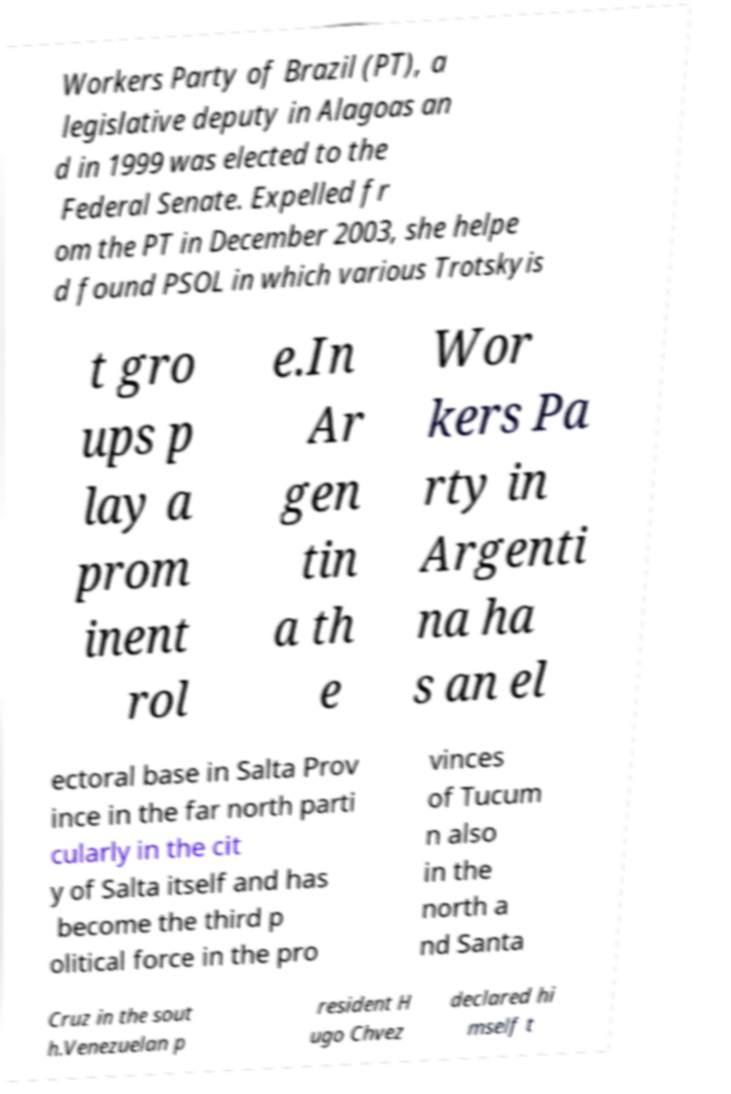For documentation purposes, I need the text within this image transcribed. Could you provide that? Workers Party of Brazil (PT), a legislative deputy in Alagoas an d in 1999 was elected to the Federal Senate. Expelled fr om the PT in December 2003, she helpe d found PSOL in which various Trotskyis t gro ups p lay a prom inent rol e.In Ar gen tin a th e Wor kers Pa rty in Argenti na ha s an el ectoral base in Salta Prov ince in the far north parti cularly in the cit y of Salta itself and has become the third p olitical force in the pro vinces of Tucum n also in the north a nd Santa Cruz in the sout h.Venezuelan p resident H ugo Chvez declared hi mself t 